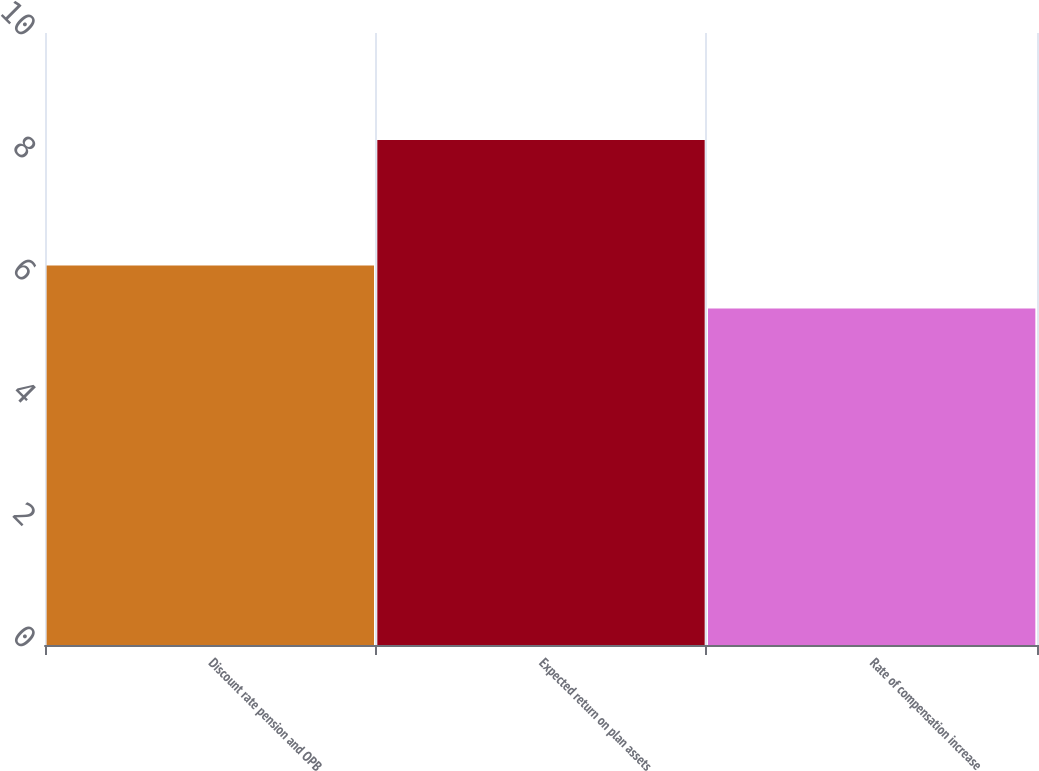Convert chart. <chart><loc_0><loc_0><loc_500><loc_500><bar_chart><fcel>Discount rate pension and OPB<fcel>Expected return on plan assets<fcel>Rate of compensation increase<nl><fcel>6.2<fcel>8.25<fcel>5.5<nl></chart> 